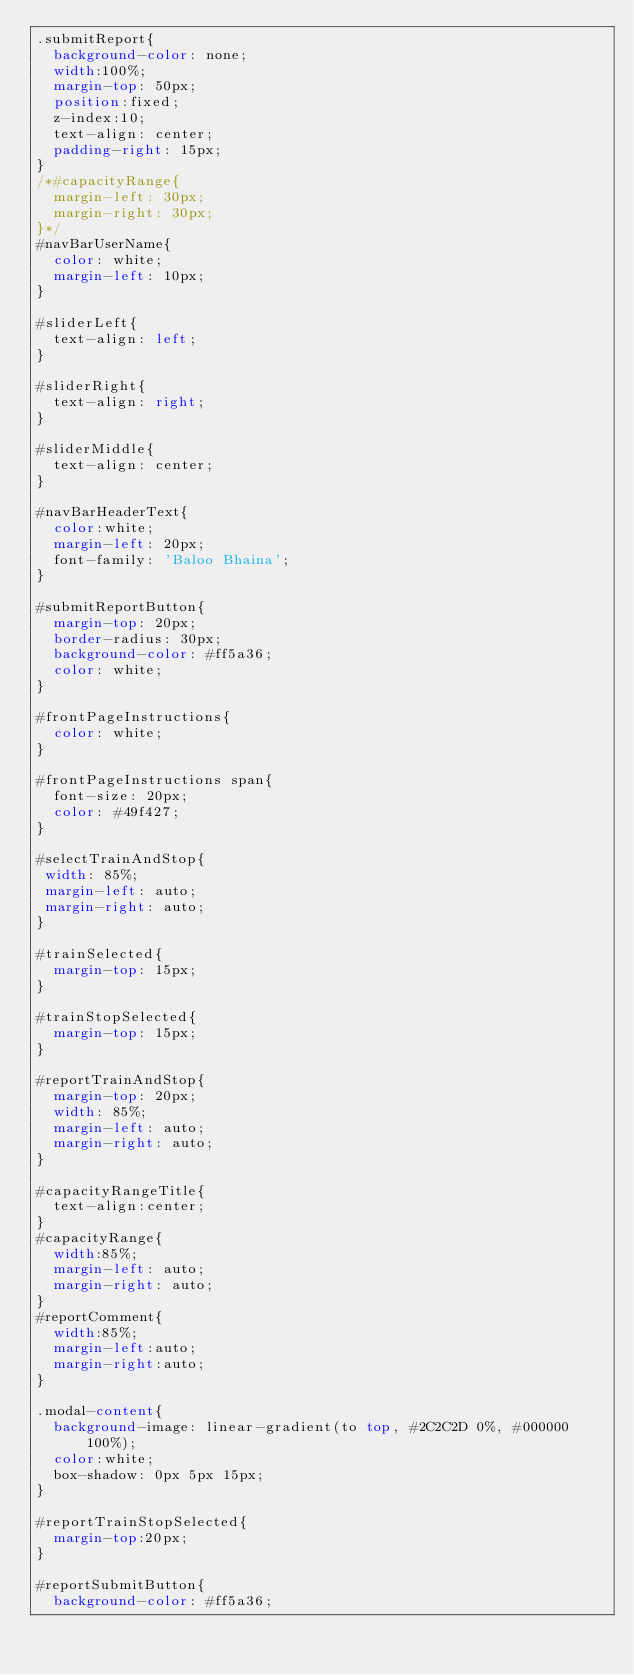<code> <loc_0><loc_0><loc_500><loc_500><_CSS_>.submitReport{
  background-color: none;
  width:100%;
  margin-top: 50px;
  position:fixed;
  z-index:10;
  text-align: center;
  padding-right: 15px;
}
/*#capacityRange{
  margin-left: 30px;
  margin-right: 30px;
}*/
#navBarUserName{
  color: white;
  margin-left: 10px;
}

#sliderLeft{
  text-align: left;
}

#sliderRight{
  text-align: right;
}

#sliderMiddle{
  text-align: center;
}

#navBarHeaderText{
  color:white;
  margin-left: 20px;
  font-family: 'Baloo Bhaina';
}

#submitReportButton{
  margin-top: 20px;
  border-radius: 30px;
  background-color: #ff5a36;
  color: white;
}

#frontPageInstructions{
  color: white;
}

#frontPageInstructions span{
  font-size: 20px;
  color: #49f427;
}

#selectTrainAndStop{
 width: 85%;
 margin-left: auto;
 margin-right: auto;
}

#trainSelected{
  margin-top: 15px;
}

#trainStopSelected{
  margin-top: 15px;
}

#reportTrainAndStop{
  margin-top: 20px;
  width: 85%;
  margin-left: auto;
  margin-right: auto;
}

#capacityRangeTitle{
  text-align:center;
}
#capacityRange{
  width:85%;
  margin-left: auto;
  margin-right: auto;
}
#reportComment{
  width:85%;
  margin-left:auto;
  margin-right:auto;
}

.modal-content{
  background-image: linear-gradient(to top, #2C2C2D 0%, #000000 100%);
  color:white;
  box-shadow: 0px 5px 15px;
}

#reportTrainStopSelected{
  margin-top:20px;
}

#reportSubmitButton{
  background-color: #ff5a36;</code> 